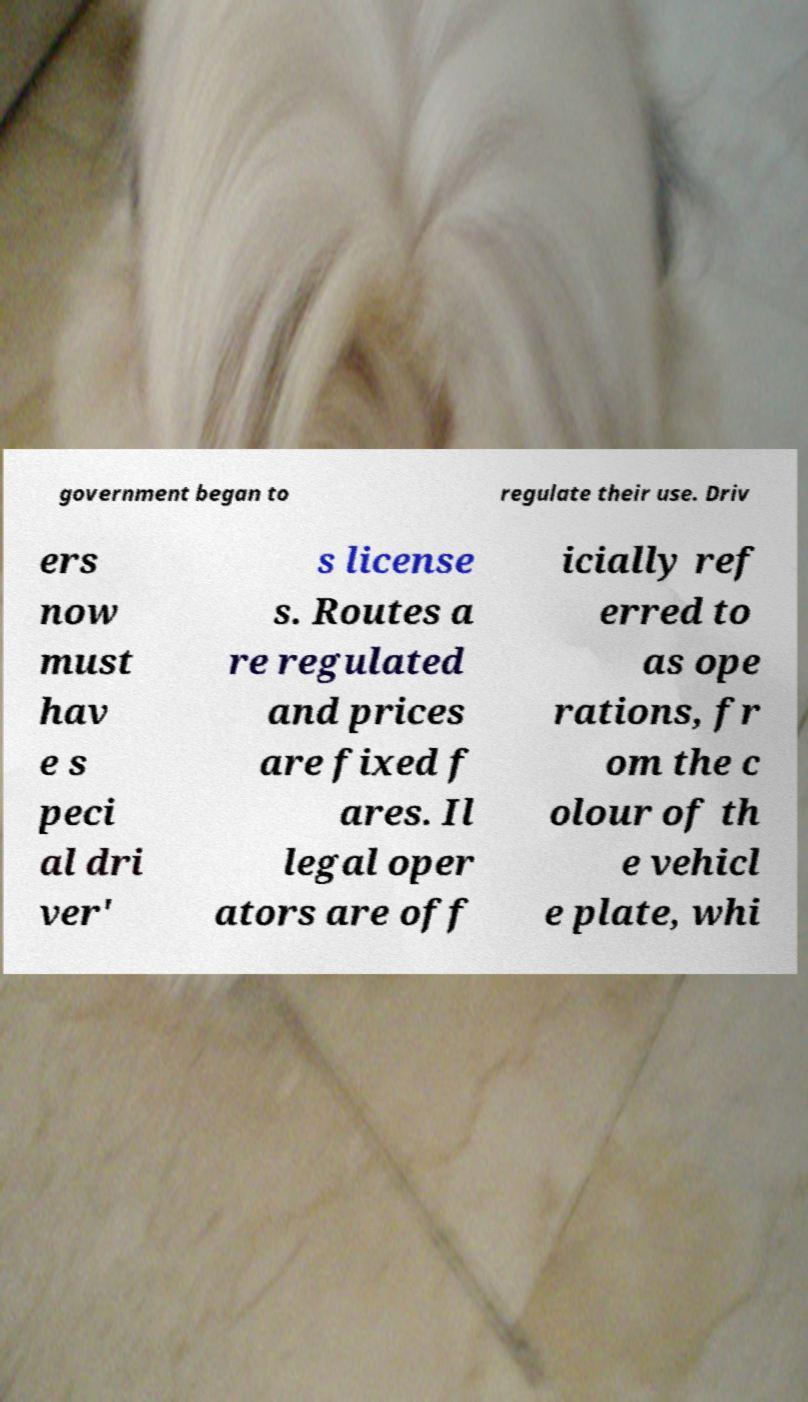I need the written content from this picture converted into text. Can you do that? government began to regulate their use. Driv ers now must hav e s peci al dri ver' s license s. Routes a re regulated and prices are fixed f ares. Il legal oper ators are off icially ref erred to as ope rations, fr om the c olour of th e vehicl e plate, whi 